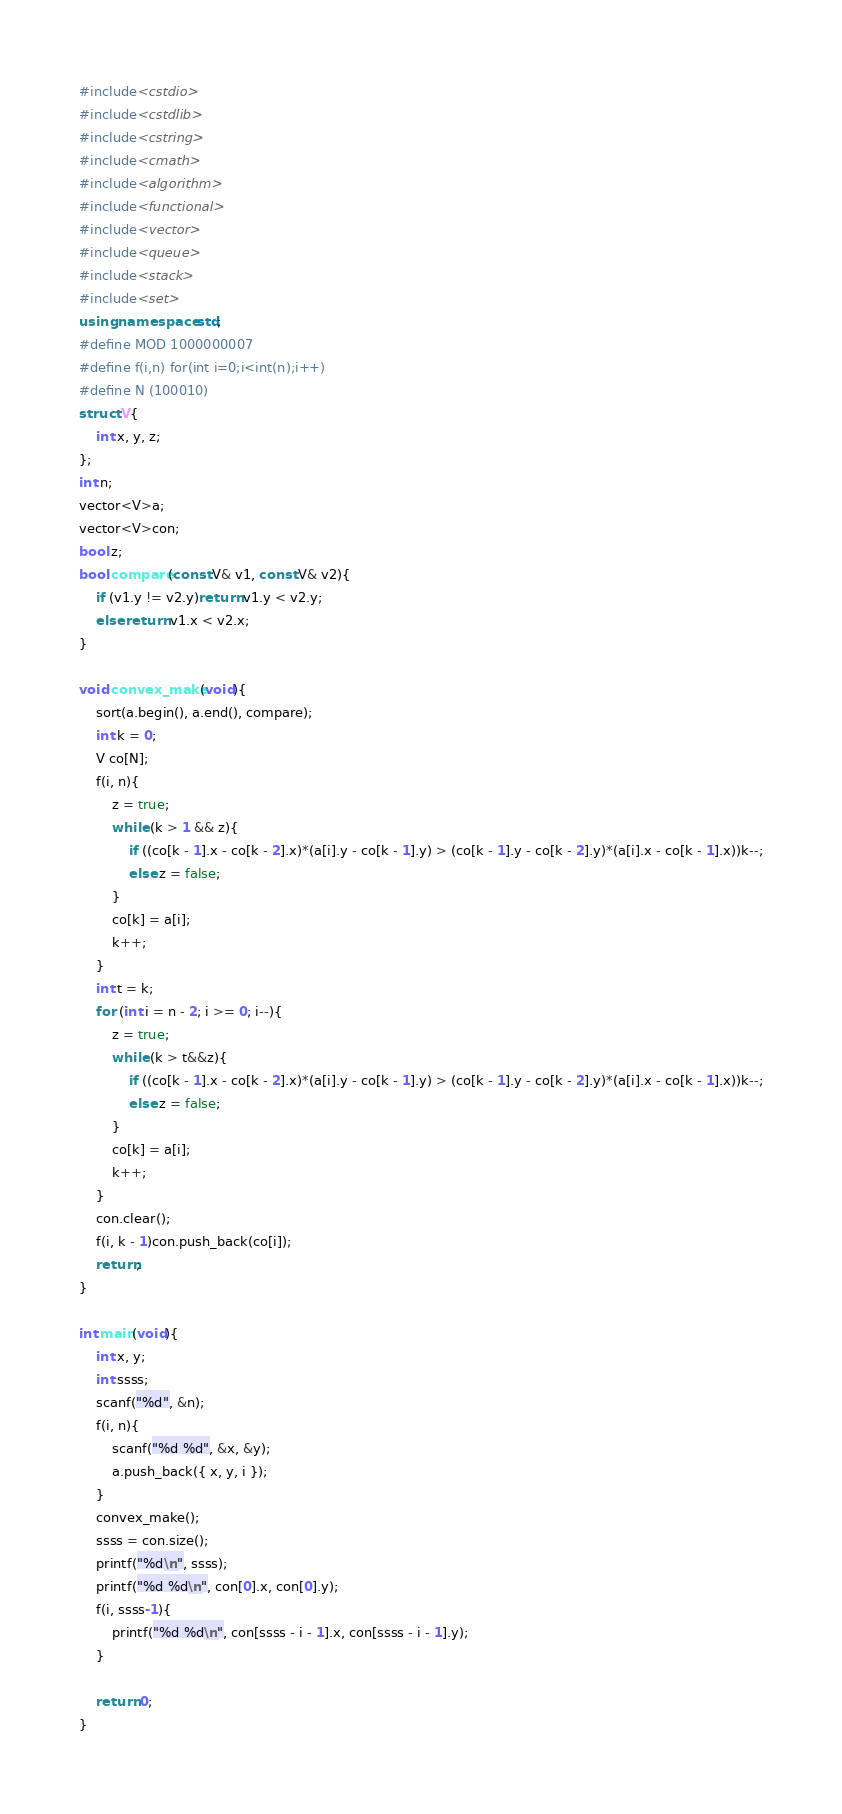Convert code to text. <code><loc_0><loc_0><loc_500><loc_500><_C++_>#include<cstdio>
#include<cstdlib>
#include<cstring>
#include<cmath>
#include<algorithm>
#include<functional>
#include<vector>
#include<queue>
#include<stack>
#include<set>
using namespace std;
#define MOD 1000000007
#define f(i,n) for(int i=0;i<int(n);i++)
#define N (100010)
struct V{
	int x, y, z;
};
int n;
vector<V>a;
vector<V>con;
bool z;
bool compare(const V& v1, const V& v2){
	if (v1.y != v2.y)return v1.y < v2.y;
	else return v1.x < v2.x;
}

void convex_make(void){
	sort(a.begin(), a.end(), compare);
	int k = 0;
	V co[N];
	f(i, n){
		z = true;
		while (k > 1 && z){
			if ((co[k - 1].x - co[k - 2].x)*(a[i].y - co[k - 1].y) > (co[k - 1].y - co[k - 2].y)*(a[i].x - co[k - 1].x))k--;
			else z = false;
		}
		co[k] = a[i];
		k++;
	}
	int t = k;
	for (int i = n - 2; i >= 0; i--){
		z = true;
		while (k > t&&z){
			if ((co[k - 1].x - co[k - 2].x)*(a[i].y - co[k - 1].y) > (co[k - 1].y - co[k - 2].y)*(a[i].x - co[k - 1].x))k--;
			else z = false;
		}
		co[k] = a[i];
		k++;
	}
	con.clear();
	f(i, k - 1)con.push_back(co[i]);
	return;
}

int main(void){
	int x, y;
	int ssss;
	scanf("%d", &n);
	f(i, n){
		scanf("%d %d", &x, &y);
		a.push_back({ x, y, i });
	}
	convex_make();
	ssss = con.size();
	printf("%d\n", ssss);
	printf("%d %d\n", con[0].x, con[0].y);
	f(i, ssss-1){
		printf("%d %d\n", con[ssss - i - 1].x, con[ssss - i - 1].y);
	}

	return 0;
}
</code> 